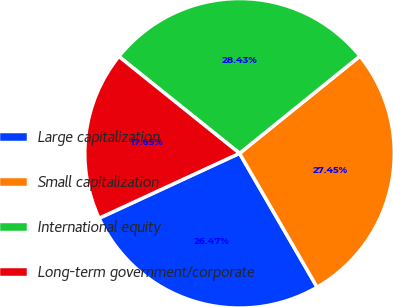Convert chart to OTSL. <chart><loc_0><loc_0><loc_500><loc_500><pie_chart><fcel>Large capitalization<fcel>Small capitalization<fcel>International equity<fcel>Long-term government/corporate<nl><fcel>26.47%<fcel>27.45%<fcel>28.43%<fcel>17.65%<nl></chart> 